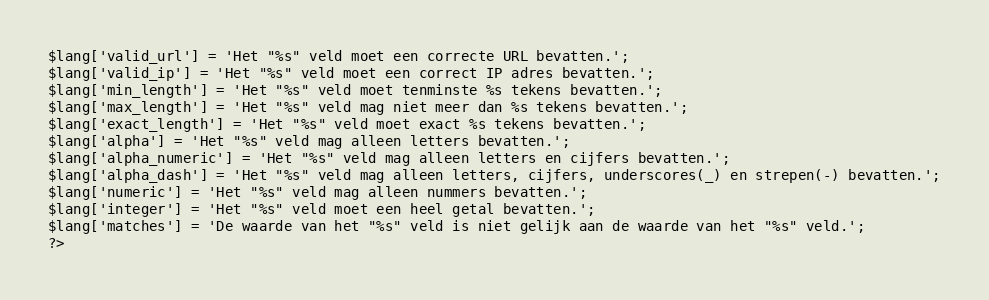<code> <loc_0><loc_0><loc_500><loc_500><_PHP_>$lang['valid_url'] = 'Het "%s" veld moet een correcte URL bevatten.';
$lang['valid_ip'] = 'Het "%s" veld moet een correct IP adres bevatten.';
$lang['min_length'] = 'Het "%s" veld moet tenminste %s tekens bevatten.';
$lang['max_length'] = 'Het "%s" veld mag niet meer dan %s tekens bevatten.';
$lang['exact_length'] = 'Het "%s" veld moet exact %s tekens bevatten.';
$lang['alpha'] = 'Het "%s" veld mag alleen letters bevatten.';
$lang['alpha_numeric'] = 'Het "%s" veld mag alleen letters en cijfers bevatten.';
$lang['alpha_dash'] = 'Het "%s" veld mag alleen letters, cijfers, underscores(_) en strepen(-) bevatten.';
$lang['numeric'] = 'Het "%s" veld mag alleen nummers bevatten.';
$lang['integer'] = 'Het "%s" veld moet een heel getal bevatten.';
$lang['matches'] = 'De waarde van het "%s" veld is niet gelijk aan de waarde van het "%s" veld.';
?></code> 